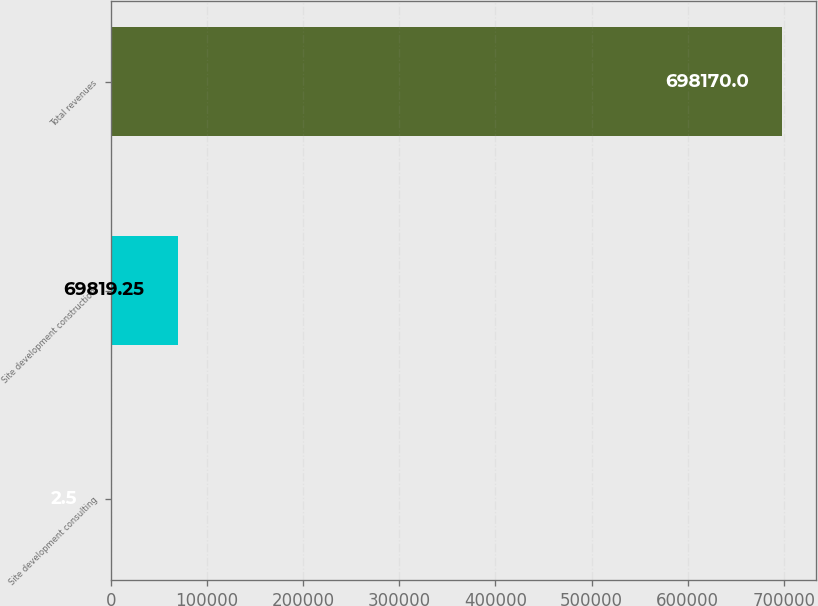Convert chart to OTSL. <chart><loc_0><loc_0><loc_500><loc_500><bar_chart><fcel>Site development consulting<fcel>Site development construction<fcel>Total revenues<nl><fcel>2.5<fcel>69819.2<fcel>698170<nl></chart> 